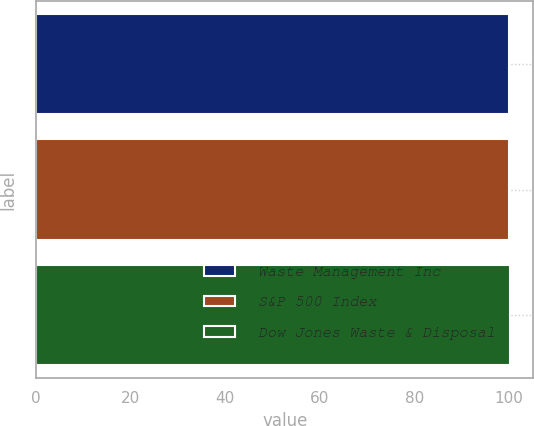Convert chart. <chart><loc_0><loc_0><loc_500><loc_500><bar_chart><fcel>Waste Management Inc<fcel>S&P 500 Index<fcel>Dow Jones Waste & Disposal<nl><fcel>100<fcel>100.1<fcel>100.2<nl></chart> 